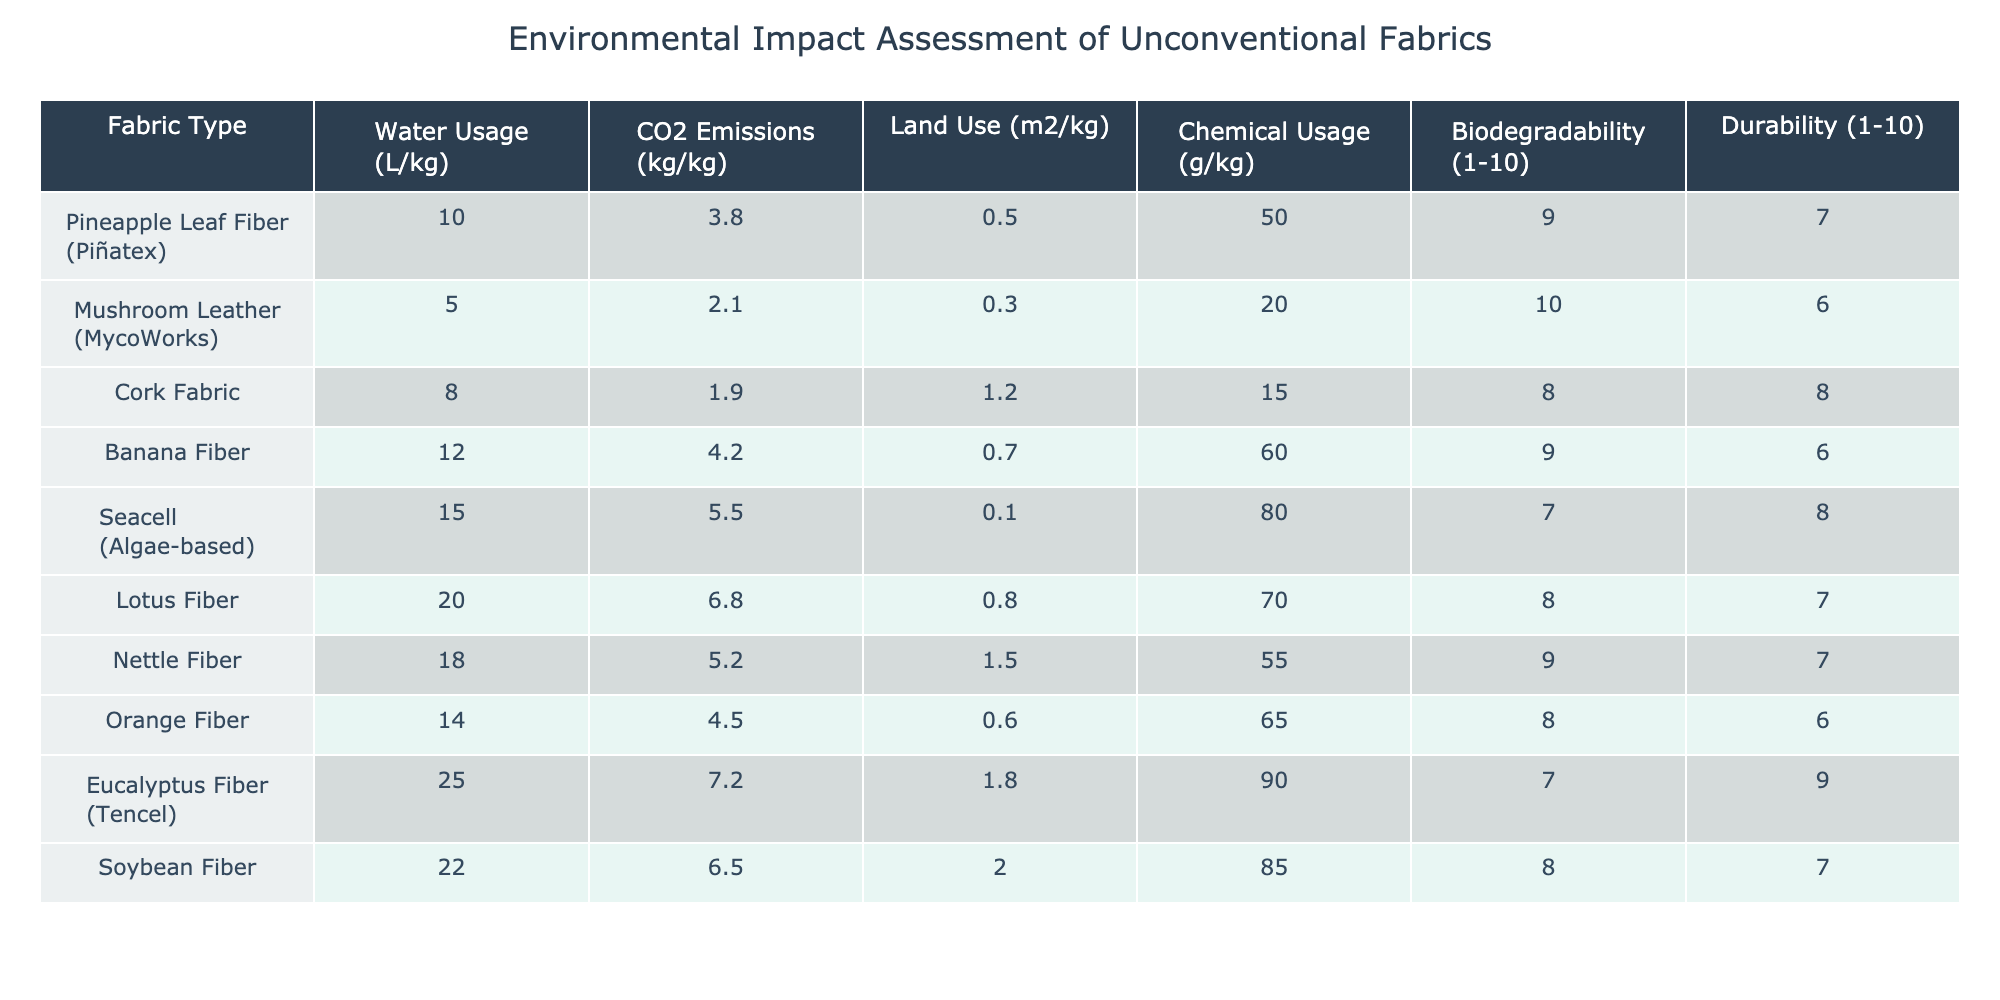What is the water usage for Mushroom Leather? The table shows that Mushroom Leather has a water usage of 5 liters per kilogram.
Answer: 5 L/kg Which fabric has the highest CO2 emissions? By examining the CO2 emissions column, Lotus Fiber has the highest emissions at 6.8 kg per kilogram.
Answer: 6.8 kg/kg What is the average land use of the fabrics listed? To find the average, sum the land use values: 0.5 + 0.3 + 1.2 + 0.7 + 0.1 + 0.8 + 1.5 + 0.6 + 1.8 + 2.0 = 9.5; there are 10 fabrics, so the average is 9.5/10 = 0.95.
Answer: 0.95 m²/kg Is the durability of Seacell higher than that of Orange Fiber? Seacell has a durability rating of 8 while Orange Fiber has a rating of 6. Therefore, yes, Seacell's durability is higher.
Answer: Yes Which fabrics are biodegradable rated 9 or higher? The biodegradable ratings show that Pineapple Leaf Fiber and Banana Fiber both have ratings of 9.
Answer: Pineapple Leaf Fiber, Banana Fiber What is the total chemical usage for the fabrics listed? Adding the chemical usage amounts gives: 50 + 20 + 15 + 60 + 80 + 70 + 55 + 65 + 90 + 85 =  660 grams per kilogram of fabrics in total.
Answer: 660 g/kg Is there a fabric with less than 10 grams of chemical usage? The minimum chemical usage in the table is 15 grams for Cork Fabric, so no fabric fits that criterion.
Answer: No Which fabric has the lowest water usage and what is it? The table shows that Mushroom Leather has the lowest water usage of 5 L/kg.
Answer: Mushroom Leather, 5 L/kg What is the difference in CO2 emissions between Lotus Fiber and Cork Fabric? Taking the CO2 emissions for both: Lotus Fiber is 6.8 kg/kg and Cork Fabric is 1.9 kg/kg; the difference is 6.8 - 1.9 = 4.9 kg/kg.
Answer: 4.9 kg/kg Which fabric has the highest durability rating, and what is that rating? From the durability column, Eucalyptus Fiber has the highest rating of 9.
Answer: Eucalyptus Fiber, 9 